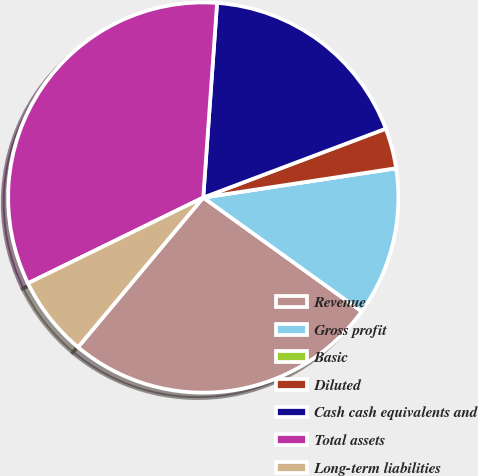Convert chart to OTSL. <chart><loc_0><loc_0><loc_500><loc_500><pie_chart><fcel>Revenue<fcel>Gross profit<fcel>Basic<fcel>Diluted<fcel>Cash cash equivalents and<fcel>Total assets<fcel>Long-term liabilities<nl><fcel>26.17%<fcel>12.32%<fcel>0.0%<fcel>3.34%<fcel>18.13%<fcel>33.37%<fcel>6.67%<nl></chart> 